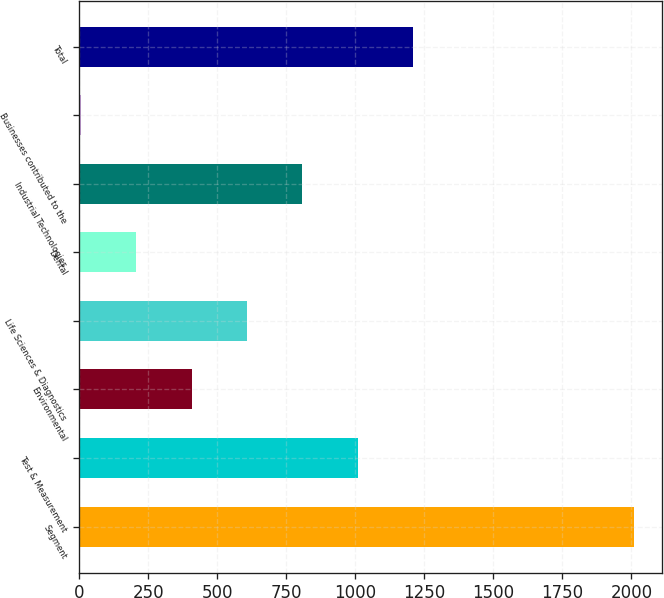Convert chart. <chart><loc_0><loc_0><loc_500><loc_500><bar_chart><fcel>Segment<fcel>Test & Measurement<fcel>Environmental<fcel>Life Sciences & Diagnostics<fcel>Dental<fcel>Industrial Technologies<fcel>Businesses contributed to the<fcel>Total<nl><fcel>2009<fcel>1007.5<fcel>406.6<fcel>606.9<fcel>206.3<fcel>807.2<fcel>6<fcel>1207.8<nl></chart> 